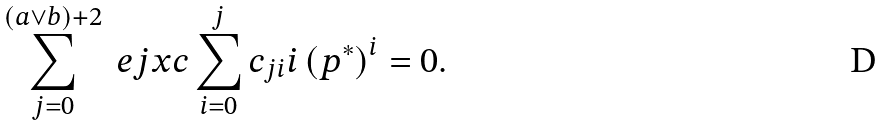Convert formula to latex. <formula><loc_0><loc_0><loc_500><loc_500>\sum _ { j = 0 } ^ { ( a \vee b ) + 2 } \ e j x c \sum _ { i = 0 } ^ { j } c _ { j i } i \left ( p ^ { \ast } \right ) ^ { i } = 0 .</formula> 